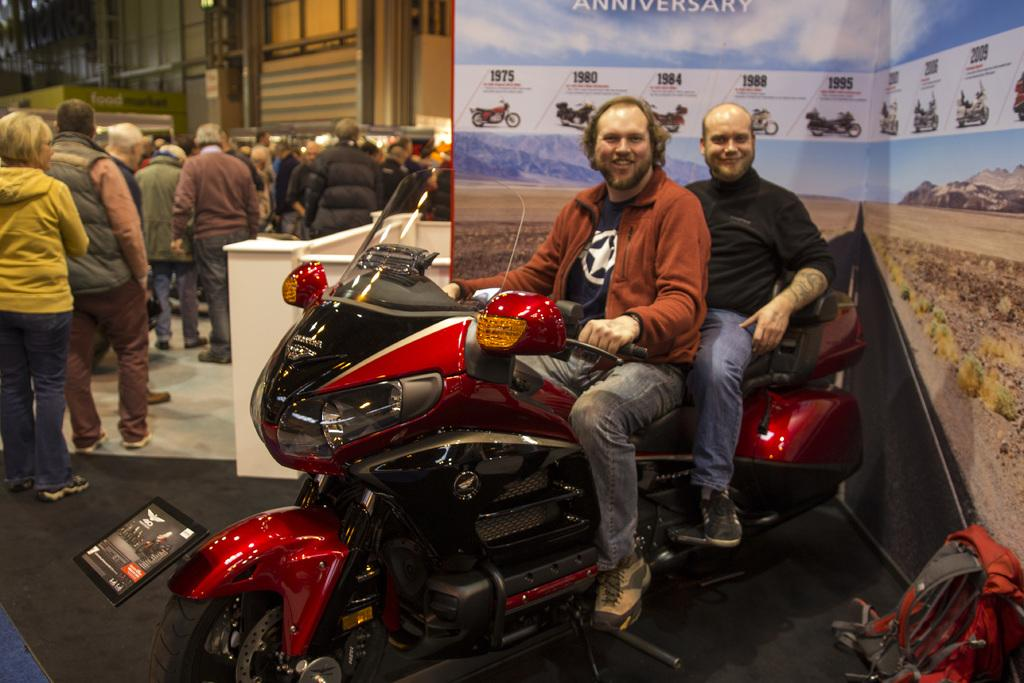What are the two people doing on the bike in the image? The two people are sitting on a bike and posing. Can you describe the group of people near the bike? There is a group of people beside the bike, and they are facing the opposite side. What type of disgust can be seen on the faces of the people in the image? There is no indication of disgust on the faces of the people in the image. What color is the giraffe in the image? There is no giraffe present in the image. 